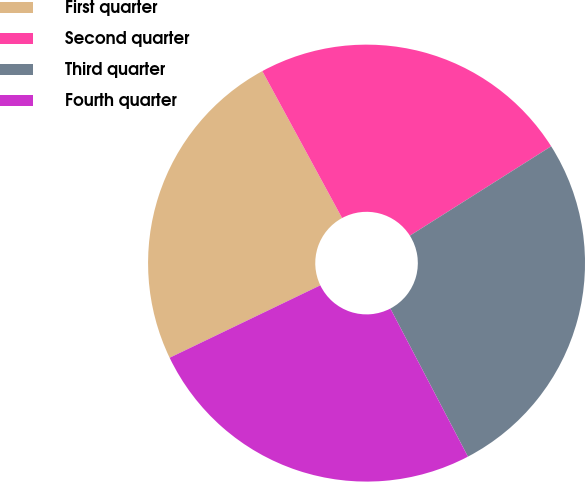Convert chart to OTSL. <chart><loc_0><loc_0><loc_500><loc_500><pie_chart><fcel>First quarter<fcel>Second quarter<fcel>Third quarter<fcel>Fourth quarter<nl><fcel>24.22%<fcel>23.94%<fcel>26.3%<fcel>25.55%<nl></chart> 